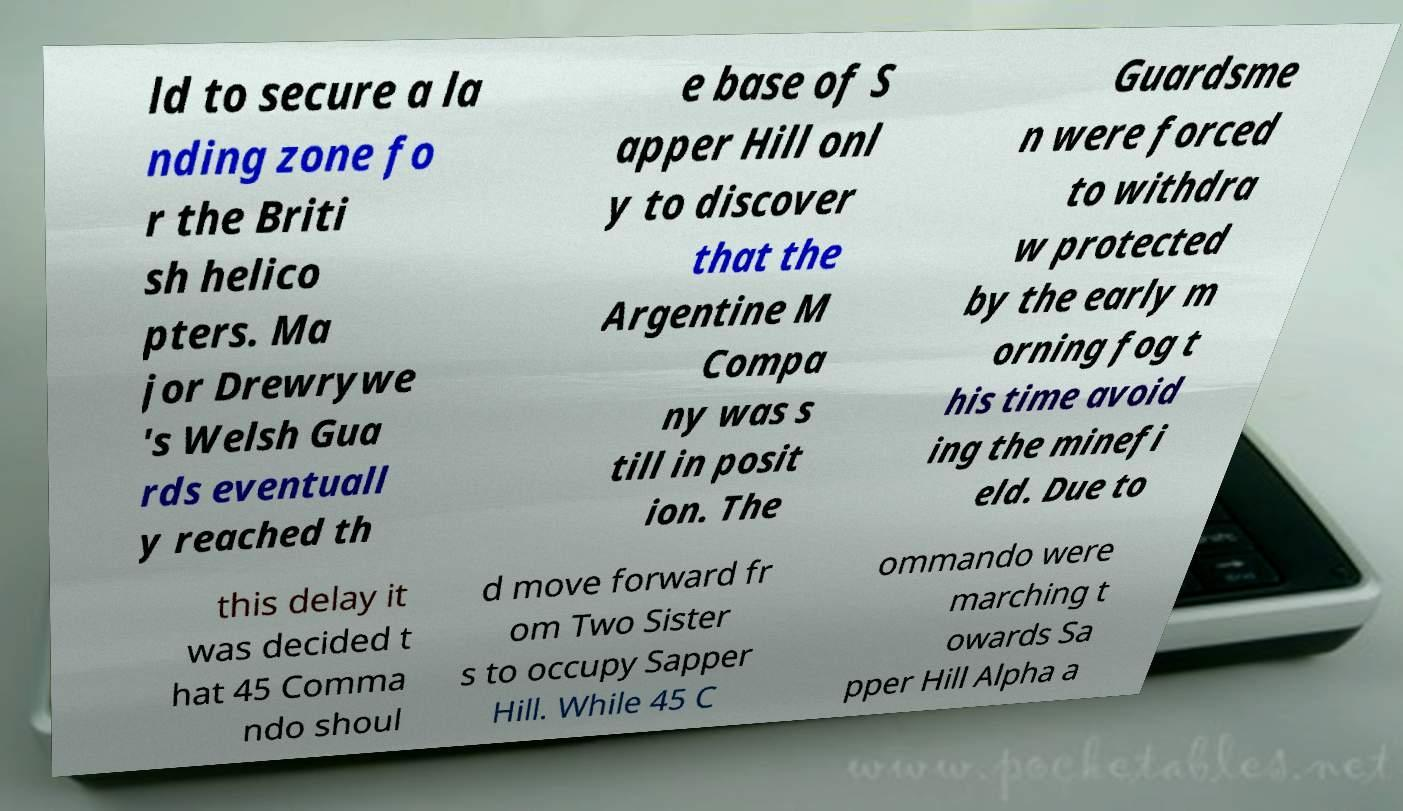There's text embedded in this image that I need extracted. Can you transcribe it verbatim? ld to secure a la nding zone fo r the Briti sh helico pters. Ma jor Drewrywe 's Welsh Gua rds eventuall y reached th e base of S apper Hill onl y to discover that the Argentine M Compa ny was s till in posit ion. The Guardsme n were forced to withdra w protected by the early m orning fog t his time avoid ing the minefi eld. Due to this delay it was decided t hat 45 Comma ndo shoul d move forward fr om Two Sister s to occupy Sapper Hill. While 45 C ommando were marching t owards Sa pper Hill Alpha a 